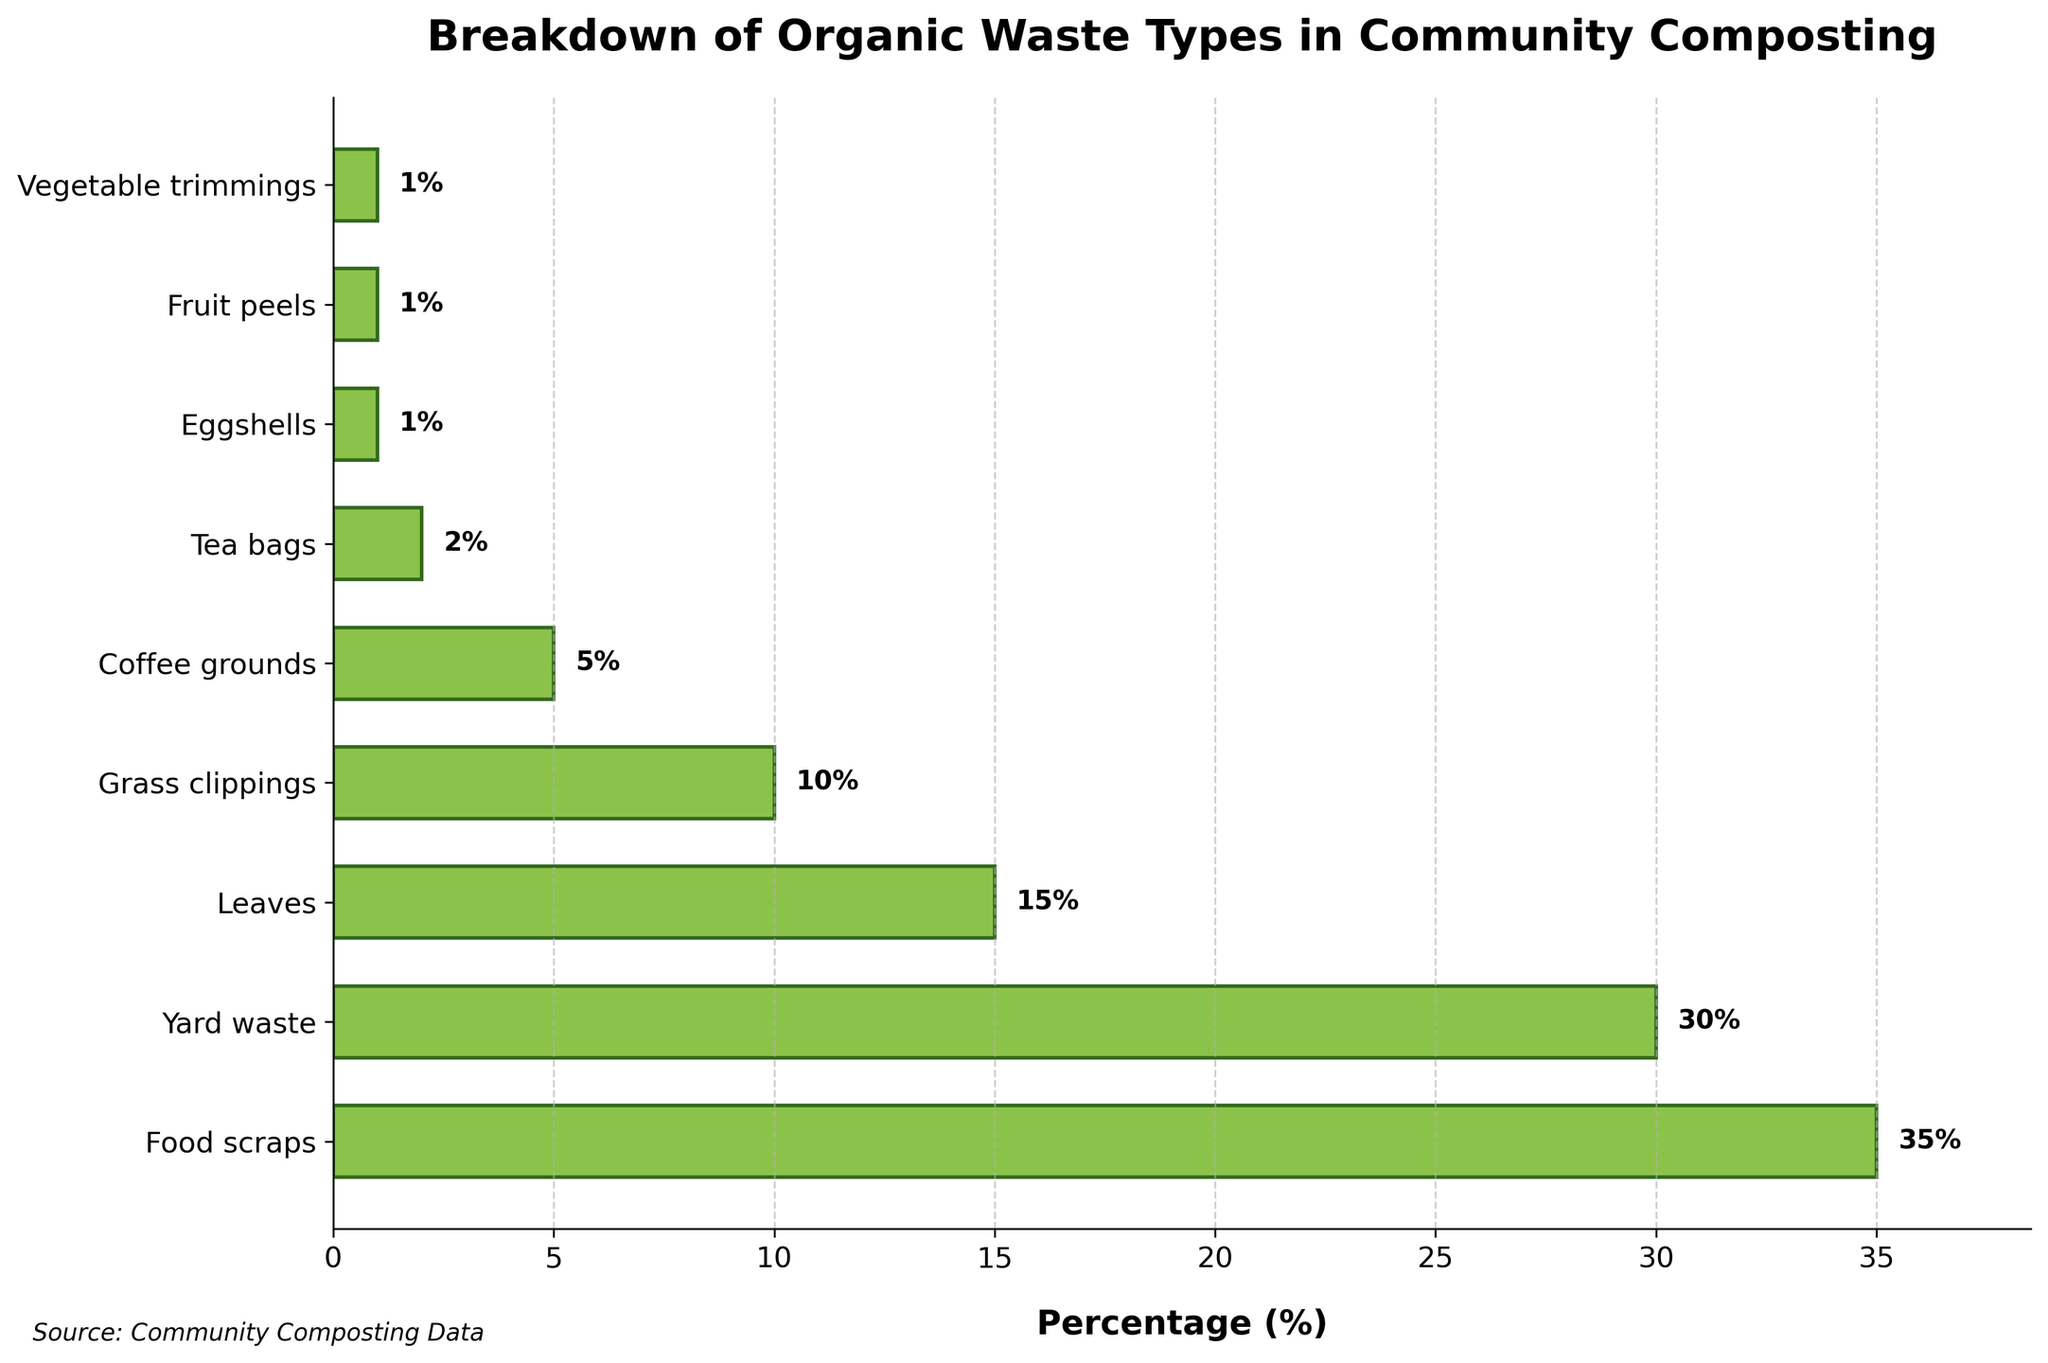What type of organic waste has the highest percentage in this community composting program? To find the type of organic waste with the highest percentage, look at the bar that extends the furthest to the right. The green bar for "Food scraps" extends to 35%, which is the highest percentage.
Answer: Food scraps Which waste type has a larger percentage, Yard waste or Leaves? To compare Yard waste and Leaves, look at their corresponding bars. Yard waste has a 30% bar, and Leaves have a 15% bar. 30% is larger than 15%, so Yard waste has a larger percentage.
Answer: Yard waste What is the total percentage represented by Coffee grounds, Tea bags, Eggshells, Fruit peels, and Vegetable trimmings combined? Sum the percentages of these waste types: Coffee grounds (5%) + Tea bags (2%) + Eggshells (1%) + Fruit peels (1%) + Vegetable trimmings (1%). The total is 5% + 2% + 1% + 1% + 1% = 10%.
Answer: 10% What are the visual characteristics of the bar representing the type with the smallest percentage? Look for the shortest bar, which represents the waste type with the smallest percentage. The shortest bar is for Eggshells, Fruit peels, and Vegetable trimmings, each at 1%. These bars are the shortest and have the same height.
Answer: Shortest bar at 1% Is the length of the Grass clippings bar greater than half the length of the Food scraps bar? Compare the length of the Grass clippings bar (10%) and divide the Food scraps bar length by two (35% / 2 = 17.5%). The Grass clippings bar at 10% is smaller than 17.5%, so it's not greater than half the length of the Food scraps bar.
Answer: No What is the average percentage of all the organic waste types shown? To calculate the average, sum all the percentages and divide by the number of waste types. The sum is 35% + 30% + 15% + 10% + 5% + 2% + 1% + 1% + 1% = 100%. There are 9 waste types. So, the average is 100% / 9 ≈ 11.11%.
Answer: 11.11% Which two types of organic waste together make up half of the total percentage? We need to find the sum of two types that add up to approximately 50%. Food scraps (35%) and Yard waste (30%) together are 35% + 30% = 65%, which is too high. The next two highest types are Yard waste (30%) and Leaves (15%), which sum 30% + 15% = 45%, which is close but not exactly half. Upon reevaluation, no such match exactly fits 50%.
Answer: None What percentage of the total organic waste is contributed by types that account for less than 5% each? Identify the waste types with less than 5% and sum their percentages: Tea bags (2%) + Eggshells (1%) + Fruit peels (1%) + Vegetable trimmings (1%). The total is 2% + 1% + 1% + 1% = 5%.
Answer: 5% Which bar is half the length of the Yard waste bar or closest to it? The Yard waste bar is 30%, and half of it is 30% / 2 = 15%. The bar closest to 15% is Leaves at exactly 15%.
Answer: Leaves 